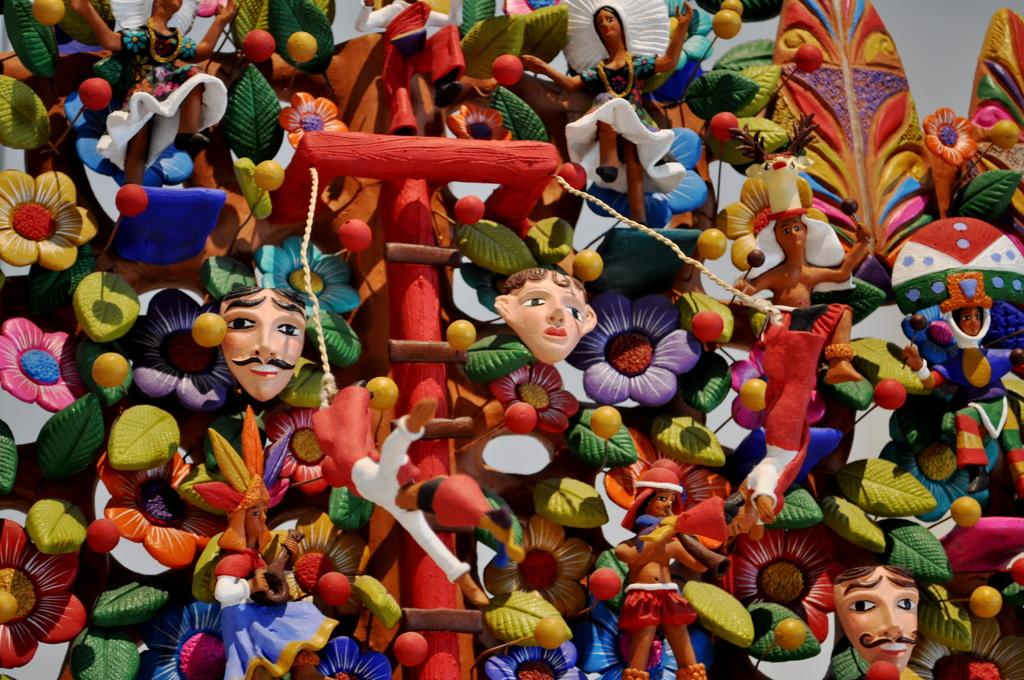What type of items can be seen in the image? There are toys in the image. Can you describe the appearance of these items? The toys are colorful objects in the image. What time of day is depicted in the image? The time of day is not mentioned or depicted in the image. Is there any eggnog visible in the image? There is no mention or depiction of eggnog in the image. 